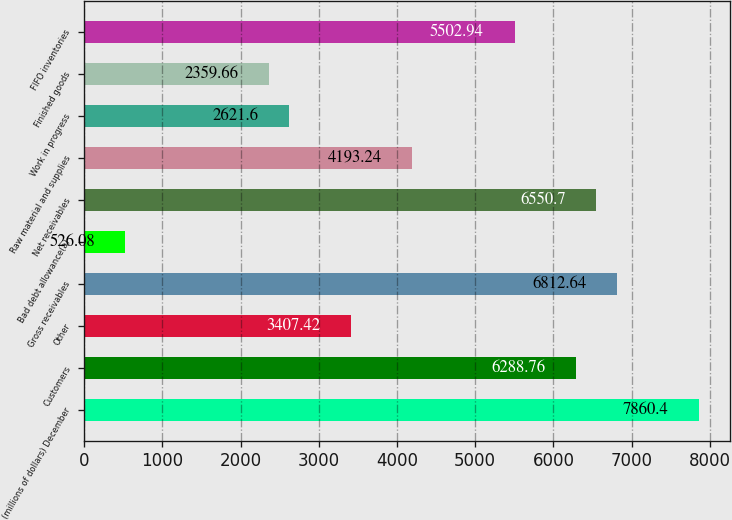Convert chart. <chart><loc_0><loc_0><loc_500><loc_500><bar_chart><fcel>(millions of dollars) December<fcel>Customers<fcel>Other<fcel>Gross receivables<fcel>Bad debt allowance(a)<fcel>Net receivables<fcel>Raw material and supplies<fcel>Work in progress<fcel>Finished goods<fcel>FIFO inventories<nl><fcel>7860.4<fcel>6288.76<fcel>3407.42<fcel>6812.64<fcel>526.08<fcel>6550.7<fcel>4193.24<fcel>2621.6<fcel>2359.66<fcel>5502.94<nl></chart> 